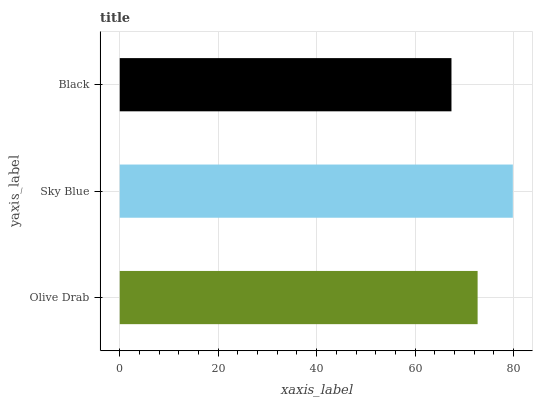Is Black the minimum?
Answer yes or no. Yes. Is Sky Blue the maximum?
Answer yes or no. Yes. Is Sky Blue the minimum?
Answer yes or no. No. Is Black the maximum?
Answer yes or no. No. Is Sky Blue greater than Black?
Answer yes or no. Yes. Is Black less than Sky Blue?
Answer yes or no. Yes. Is Black greater than Sky Blue?
Answer yes or no. No. Is Sky Blue less than Black?
Answer yes or no. No. Is Olive Drab the high median?
Answer yes or no. Yes. Is Olive Drab the low median?
Answer yes or no. Yes. Is Black the high median?
Answer yes or no. No. Is Sky Blue the low median?
Answer yes or no. No. 